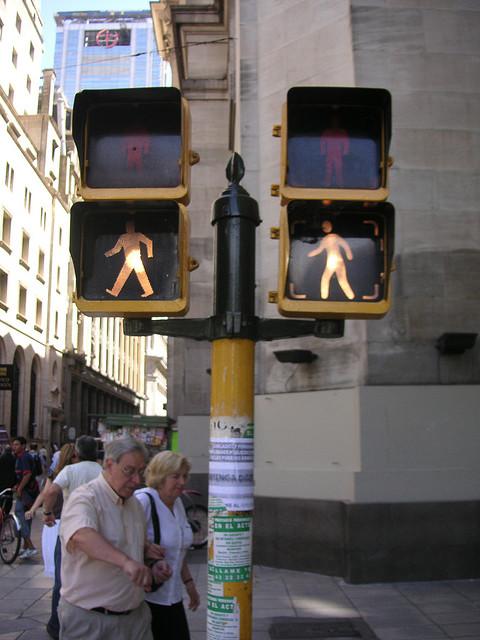Are there signs on the sign pole?
Keep it brief. Yes. Is this an elderly couple?
Answer briefly. Yes. Does the street light so to walk?
Give a very brief answer. Yes. 